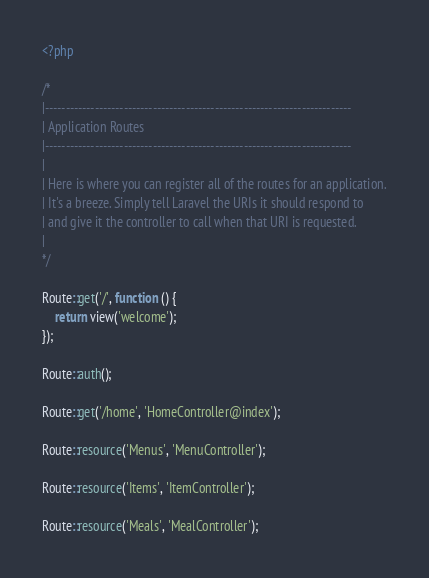Convert code to text. <code><loc_0><loc_0><loc_500><loc_500><_PHP_><?php

/*
|--------------------------------------------------------------------------
| Application Routes
|--------------------------------------------------------------------------
|
| Here is where you can register all of the routes for an application.
| It's a breeze. Simply tell Laravel the URIs it should respond to
| and give it the controller to call when that URI is requested.
|
*/

Route::get('/', function () {
    return view('welcome');
});

Route::auth();

Route::get('/home', 'HomeController@index');

Route::resource('Menus', 'MenuController');

Route::resource('Items', 'ItemController');

Route::resource('Meals', 'MealController');</code> 